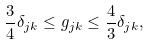<formula> <loc_0><loc_0><loc_500><loc_500>\frac { 3 } { 4 } \delta _ { j k } \leq g _ { j k } \leq \frac { 4 } { 3 } \delta _ { j k } ,</formula> 